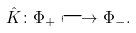<formula> <loc_0><loc_0><loc_500><loc_500>\hat { K } \colon \Phi _ { + } \longmapsto \Phi _ { - } .</formula> 